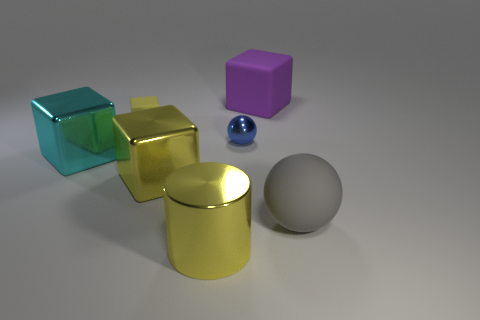Is the tiny thing that is right of the small block made of the same material as the big yellow cylinder?
Provide a short and direct response. Yes. Are there the same number of yellow matte objects that are on the right side of the big yellow cylinder and big gray rubber balls?
Give a very brief answer. No. What size is the purple matte block?
Give a very brief answer. Large. What material is the cylinder that is the same color as the small cube?
Your answer should be very brief. Metal. How many tiny metal balls have the same color as the big cylinder?
Offer a terse response. 0. Do the gray object and the yellow rubber cube have the same size?
Offer a very short reply. No. What size is the rubber cube right of the big metal thing in front of the big gray ball?
Your answer should be very brief. Large. There is a cylinder; is it the same color as the cube right of the cylinder?
Your answer should be very brief. No. Are there any purple rubber objects that have the same size as the yellow cylinder?
Keep it short and to the point. Yes. There is a yellow metal object that is behind the big gray rubber thing; what size is it?
Offer a terse response. Large. 